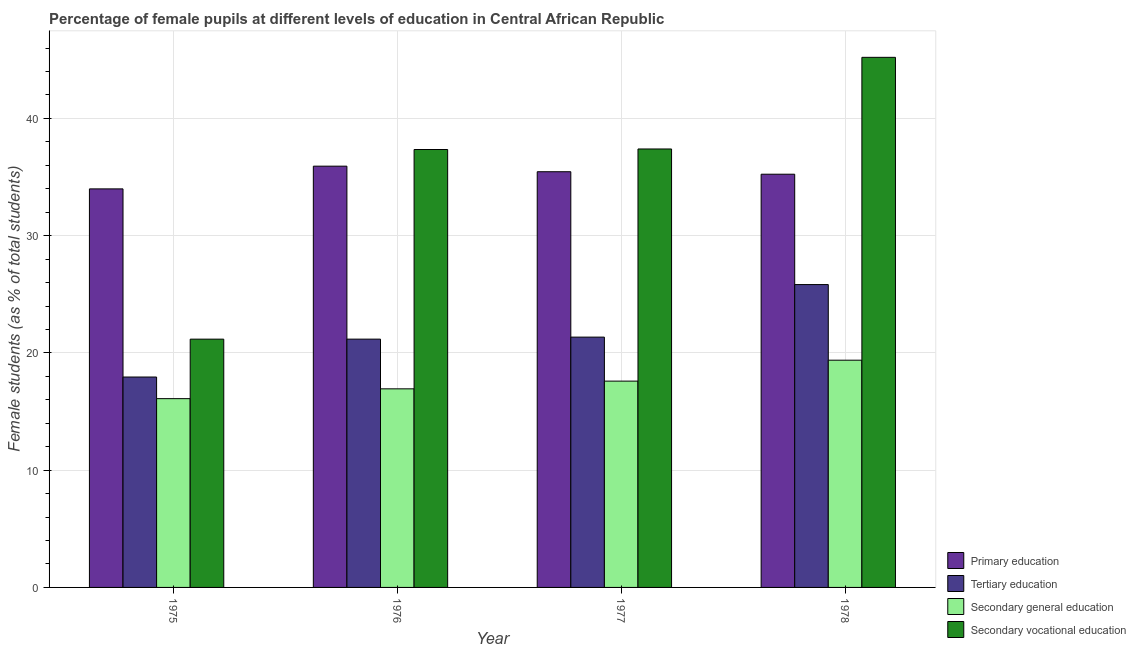Are the number of bars per tick equal to the number of legend labels?
Provide a short and direct response. Yes. What is the label of the 4th group of bars from the left?
Offer a very short reply. 1978. In how many cases, is the number of bars for a given year not equal to the number of legend labels?
Keep it short and to the point. 0. What is the percentage of female students in primary education in 1978?
Your response must be concise. 35.24. Across all years, what is the maximum percentage of female students in secondary education?
Your answer should be very brief. 19.38. Across all years, what is the minimum percentage of female students in secondary education?
Provide a succinct answer. 16.1. In which year was the percentage of female students in secondary education maximum?
Provide a succinct answer. 1978. In which year was the percentage of female students in tertiary education minimum?
Offer a terse response. 1975. What is the total percentage of female students in secondary education in the graph?
Offer a very short reply. 70.01. What is the difference between the percentage of female students in tertiary education in 1975 and that in 1976?
Your answer should be very brief. -3.23. What is the difference between the percentage of female students in tertiary education in 1976 and the percentage of female students in primary education in 1977?
Ensure brevity in your answer.  -0.17. What is the average percentage of female students in primary education per year?
Keep it short and to the point. 35.15. What is the ratio of the percentage of female students in secondary vocational education in 1977 to that in 1978?
Provide a succinct answer. 0.83. Is the difference between the percentage of female students in secondary education in 1975 and 1977 greater than the difference between the percentage of female students in primary education in 1975 and 1977?
Your answer should be very brief. No. What is the difference between the highest and the second highest percentage of female students in secondary education?
Provide a succinct answer. 1.78. What is the difference between the highest and the lowest percentage of female students in tertiary education?
Your response must be concise. 7.88. Is the sum of the percentage of female students in tertiary education in 1977 and 1978 greater than the maximum percentage of female students in primary education across all years?
Make the answer very short. Yes. What does the 2nd bar from the left in 1975 represents?
Offer a very short reply. Tertiary education. What does the 2nd bar from the right in 1978 represents?
Make the answer very short. Secondary general education. Are all the bars in the graph horizontal?
Your answer should be very brief. No. Are the values on the major ticks of Y-axis written in scientific E-notation?
Provide a short and direct response. No. Does the graph contain any zero values?
Make the answer very short. No. Does the graph contain grids?
Offer a very short reply. Yes. How are the legend labels stacked?
Your answer should be very brief. Vertical. What is the title of the graph?
Offer a very short reply. Percentage of female pupils at different levels of education in Central African Republic. What is the label or title of the X-axis?
Keep it short and to the point. Year. What is the label or title of the Y-axis?
Provide a short and direct response. Female students (as % of total students). What is the Female students (as % of total students) in Primary education in 1975?
Provide a short and direct response. 33.99. What is the Female students (as % of total students) in Tertiary education in 1975?
Offer a terse response. 17.94. What is the Female students (as % of total students) of Secondary general education in 1975?
Provide a short and direct response. 16.1. What is the Female students (as % of total students) in Secondary vocational education in 1975?
Your response must be concise. 21.17. What is the Female students (as % of total students) in Primary education in 1976?
Ensure brevity in your answer.  35.93. What is the Female students (as % of total students) of Tertiary education in 1976?
Provide a short and direct response. 21.18. What is the Female students (as % of total students) of Secondary general education in 1976?
Your answer should be compact. 16.94. What is the Female students (as % of total students) of Secondary vocational education in 1976?
Provide a succinct answer. 37.35. What is the Female students (as % of total students) in Primary education in 1977?
Your response must be concise. 35.45. What is the Female students (as % of total students) of Tertiary education in 1977?
Provide a short and direct response. 21.35. What is the Female students (as % of total students) in Secondary general education in 1977?
Your response must be concise. 17.6. What is the Female students (as % of total students) in Secondary vocational education in 1977?
Give a very brief answer. 37.39. What is the Female students (as % of total students) of Primary education in 1978?
Ensure brevity in your answer.  35.24. What is the Female students (as % of total students) in Tertiary education in 1978?
Ensure brevity in your answer.  25.83. What is the Female students (as % of total students) of Secondary general education in 1978?
Your answer should be very brief. 19.38. What is the Female students (as % of total students) in Secondary vocational education in 1978?
Your answer should be compact. 45.21. Across all years, what is the maximum Female students (as % of total students) in Primary education?
Provide a succinct answer. 35.93. Across all years, what is the maximum Female students (as % of total students) in Tertiary education?
Offer a terse response. 25.83. Across all years, what is the maximum Female students (as % of total students) in Secondary general education?
Offer a terse response. 19.38. Across all years, what is the maximum Female students (as % of total students) in Secondary vocational education?
Provide a short and direct response. 45.21. Across all years, what is the minimum Female students (as % of total students) of Primary education?
Keep it short and to the point. 33.99. Across all years, what is the minimum Female students (as % of total students) in Tertiary education?
Ensure brevity in your answer.  17.94. Across all years, what is the minimum Female students (as % of total students) of Secondary general education?
Your answer should be very brief. 16.1. Across all years, what is the minimum Female students (as % of total students) of Secondary vocational education?
Provide a short and direct response. 21.17. What is the total Female students (as % of total students) of Primary education in the graph?
Make the answer very short. 140.61. What is the total Female students (as % of total students) in Tertiary education in the graph?
Make the answer very short. 86.3. What is the total Female students (as % of total students) of Secondary general education in the graph?
Offer a terse response. 70.01. What is the total Female students (as % of total students) of Secondary vocational education in the graph?
Your response must be concise. 141.13. What is the difference between the Female students (as % of total students) of Primary education in 1975 and that in 1976?
Your response must be concise. -1.94. What is the difference between the Female students (as % of total students) of Tertiary education in 1975 and that in 1976?
Offer a very short reply. -3.23. What is the difference between the Female students (as % of total students) in Secondary general education in 1975 and that in 1976?
Give a very brief answer. -0.84. What is the difference between the Female students (as % of total students) in Secondary vocational education in 1975 and that in 1976?
Give a very brief answer. -16.17. What is the difference between the Female students (as % of total students) of Primary education in 1975 and that in 1977?
Provide a short and direct response. -1.46. What is the difference between the Female students (as % of total students) in Tertiary education in 1975 and that in 1977?
Keep it short and to the point. -3.4. What is the difference between the Female students (as % of total students) in Secondary general education in 1975 and that in 1977?
Keep it short and to the point. -1.5. What is the difference between the Female students (as % of total students) in Secondary vocational education in 1975 and that in 1977?
Give a very brief answer. -16.22. What is the difference between the Female students (as % of total students) in Primary education in 1975 and that in 1978?
Offer a terse response. -1.25. What is the difference between the Female students (as % of total students) of Tertiary education in 1975 and that in 1978?
Provide a short and direct response. -7.88. What is the difference between the Female students (as % of total students) in Secondary general education in 1975 and that in 1978?
Your response must be concise. -3.28. What is the difference between the Female students (as % of total students) in Secondary vocational education in 1975 and that in 1978?
Your answer should be compact. -24.04. What is the difference between the Female students (as % of total students) of Primary education in 1976 and that in 1977?
Provide a short and direct response. 0.47. What is the difference between the Female students (as % of total students) of Tertiary education in 1976 and that in 1977?
Offer a terse response. -0.17. What is the difference between the Female students (as % of total students) in Secondary general education in 1976 and that in 1977?
Provide a succinct answer. -0.66. What is the difference between the Female students (as % of total students) of Secondary vocational education in 1976 and that in 1977?
Provide a short and direct response. -0.05. What is the difference between the Female students (as % of total students) of Primary education in 1976 and that in 1978?
Offer a very short reply. 0.69. What is the difference between the Female students (as % of total students) in Tertiary education in 1976 and that in 1978?
Provide a succinct answer. -4.65. What is the difference between the Female students (as % of total students) in Secondary general education in 1976 and that in 1978?
Provide a short and direct response. -2.44. What is the difference between the Female students (as % of total students) in Secondary vocational education in 1976 and that in 1978?
Offer a very short reply. -7.86. What is the difference between the Female students (as % of total students) in Primary education in 1977 and that in 1978?
Keep it short and to the point. 0.21. What is the difference between the Female students (as % of total students) of Tertiary education in 1977 and that in 1978?
Provide a succinct answer. -4.48. What is the difference between the Female students (as % of total students) of Secondary general education in 1977 and that in 1978?
Provide a short and direct response. -1.78. What is the difference between the Female students (as % of total students) of Secondary vocational education in 1977 and that in 1978?
Give a very brief answer. -7.82. What is the difference between the Female students (as % of total students) of Primary education in 1975 and the Female students (as % of total students) of Tertiary education in 1976?
Provide a short and direct response. 12.81. What is the difference between the Female students (as % of total students) in Primary education in 1975 and the Female students (as % of total students) in Secondary general education in 1976?
Provide a succinct answer. 17.05. What is the difference between the Female students (as % of total students) of Primary education in 1975 and the Female students (as % of total students) of Secondary vocational education in 1976?
Your answer should be compact. -3.36. What is the difference between the Female students (as % of total students) in Tertiary education in 1975 and the Female students (as % of total students) in Secondary general education in 1976?
Provide a succinct answer. 1.01. What is the difference between the Female students (as % of total students) of Tertiary education in 1975 and the Female students (as % of total students) of Secondary vocational education in 1976?
Your answer should be compact. -19.4. What is the difference between the Female students (as % of total students) of Secondary general education in 1975 and the Female students (as % of total students) of Secondary vocational education in 1976?
Your response must be concise. -21.25. What is the difference between the Female students (as % of total students) in Primary education in 1975 and the Female students (as % of total students) in Tertiary education in 1977?
Give a very brief answer. 12.64. What is the difference between the Female students (as % of total students) in Primary education in 1975 and the Female students (as % of total students) in Secondary general education in 1977?
Your answer should be compact. 16.39. What is the difference between the Female students (as % of total students) of Primary education in 1975 and the Female students (as % of total students) of Secondary vocational education in 1977?
Your response must be concise. -3.4. What is the difference between the Female students (as % of total students) in Tertiary education in 1975 and the Female students (as % of total students) in Secondary general education in 1977?
Offer a terse response. 0.35. What is the difference between the Female students (as % of total students) of Tertiary education in 1975 and the Female students (as % of total students) of Secondary vocational education in 1977?
Give a very brief answer. -19.45. What is the difference between the Female students (as % of total students) of Secondary general education in 1975 and the Female students (as % of total students) of Secondary vocational education in 1977?
Give a very brief answer. -21.29. What is the difference between the Female students (as % of total students) in Primary education in 1975 and the Female students (as % of total students) in Tertiary education in 1978?
Make the answer very short. 8.16. What is the difference between the Female students (as % of total students) in Primary education in 1975 and the Female students (as % of total students) in Secondary general education in 1978?
Ensure brevity in your answer.  14.61. What is the difference between the Female students (as % of total students) of Primary education in 1975 and the Female students (as % of total students) of Secondary vocational education in 1978?
Provide a succinct answer. -11.22. What is the difference between the Female students (as % of total students) of Tertiary education in 1975 and the Female students (as % of total students) of Secondary general education in 1978?
Offer a very short reply. -1.43. What is the difference between the Female students (as % of total students) of Tertiary education in 1975 and the Female students (as % of total students) of Secondary vocational education in 1978?
Offer a terse response. -27.27. What is the difference between the Female students (as % of total students) in Secondary general education in 1975 and the Female students (as % of total students) in Secondary vocational education in 1978?
Offer a terse response. -29.11. What is the difference between the Female students (as % of total students) in Primary education in 1976 and the Female students (as % of total students) in Tertiary education in 1977?
Your response must be concise. 14.58. What is the difference between the Female students (as % of total students) of Primary education in 1976 and the Female students (as % of total students) of Secondary general education in 1977?
Make the answer very short. 18.33. What is the difference between the Female students (as % of total students) in Primary education in 1976 and the Female students (as % of total students) in Secondary vocational education in 1977?
Keep it short and to the point. -1.47. What is the difference between the Female students (as % of total students) in Tertiary education in 1976 and the Female students (as % of total students) in Secondary general education in 1977?
Provide a succinct answer. 3.58. What is the difference between the Female students (as % of total students) in Tertiary education in 1976 and the Female students (as % of total students) in Secondary vocational education in 1977?
Offer a terse response. -16.22. What is the difference between the Female students (as % of total students) in Secondary general education in 1976 and the Female students (as % of total students) in Secondary vocational education in 1977?
Give a very brief answer. -20.46. What is the difference between the Female students (as % of total students) of Primary education in 1976 and the Female students (as % of total students) of Tertiary education in 1978?
Offer a terse response. 10.1. What is the difference between the Female students (as % of total students) of Primary education in 1976 and the Female students (as % of total students) of Secondary general education in 1978?
Give a very brief answer. 16.55. What is the difference between the Female students (as % of total students) of Primary education in 1976 and the Female students (as % of total students) of Secondary vocational education in 1978?
Offer a terse response. -9.28. What is the difference between the Female students (as % of total students) in Tertiary education in 1976 and the Female students (as % of total students) in Secondary general education in 1978?
Your response must be concise. 1.8. What is the difference between the Female students (as % of total students) of Tertiary education in 1976 and the Female students (as % of total students) of Secondary vocational education in 1978?
Your answer should be very brief. -24.03. What is the difference between the Female students (as % of total students) of Secondary general education in 1976 and the Female students (as % of total students) of Secondary vocational education in 1978?
Make the answer very short. -28.27. What is the difference between the Female students (as % of total students) in Primary education in 1977 and the Female students (as % of total students) in Tertiary education in 1978?
Keep it short and to the point. 9.62. What is the difference between the Female students (as % of total students) of Primary education in 1977 and the Female students (as % of total students) of Secondary general education in 1978?
Provide a succinct answer. 16.07. What is the difference between the Female students (as % of total students) of Primary education in 1977 and the Female students (as % of total students) of Secondary vocational education in 1978?
Make the answer very short. -9.76. What is the difference between the Female students (as % of total students) of Tertiary education in 1977 and the Female students (as % of total students) of Secondary general education in 1978?
Your response must be concise. 1.97. What is the difference between the Female students (as % of total students) of Tertiary education in 1977 and the Female students (as % of total students) of Secondary vocational education in 1978?
Your response must be concise. -23.86. What is the difference between the Female students (as % of total students) in Secondary general education in 1977 and the Female students (as % of total students) in Secondary vocational education in 1978?
Provide a short and direct response. -27.61. What is the average Female students (as % of total students) in Primary education per year?
Your answer should be very brief. 35.15. What is the average Female students (as % of total students) in Tertiary education per year?
Keep it short and to the point. 21.57. What is the average Female students (as % of total students) in Secondary general education per year?
Give a very brief answer. 17.5. What is the average Female students (as % of total students) in Secondary vocational education per year?
Make the answer very short. 35.28. In the year 1975, what is the difference between the Female students (as % of total students) in Primary education and Female students (as % of total students) in Tertiary education?
Keep it short and to the point. 16.05. In the year 1975, what is the difference between the Female students (as % of total students) in Primary education and Female students (as % of total students) in Secondary general education?
Provide a succinct answer. 17.89. In the year 1975, what is the difference between the Female students (as % of total students) in Primary education and Female students (as % of total students) in Secondary vocational education?
Ensure brevity in your answer.  12.82. In the year 1975, what is the difference between the Female students (as % of total students) in Tertiary education and Female students (as % of total students) in Secondary general education?
Offer a terse response. 1.84. In the year 1975, what is the difference between the Female students (as % of total students) of Tertiary education and Female students (as % of total students) of Secondary vocational education?
Ensure brevity in your answer.  -3.23. In the year 1975, what is the difference between the Female students (as % of total students) of Secondary general education and Female students (as % of total students) of Secondary vocational education?
Offer a very short reply. -5.07. In the year 1976, what is the difference between the Female students (as % of total students) in Primary education and Female students (as % of total students) in Tertiary education?
Give a very brief answer. 14.75. In the year 1976, what is the difference between the Female students (as % of total students) of Primary education and Female students (as % of total students) of Secondary general education?
Give a very brief answer. 18.99. In the year 1976, what is the difference between the Female students (as % of total students) in Primary education and Female students (as % of total students) in Secondary vocational education?
Give a very brief answer. -1.42. In the year 1976, what is the difference between the Female students (as % of total students) in Tertiary education and Female students (as % of total students) in Secondary general education?
Keep it short and to the point. 4.24. In the year 1976, what is the difference between the Female students (as % of total students) of Tertiary education and Female students (as % of total students) of Secondary vocational education?
Your answer should be compact. -16.17. In the year 1976, what is the difference between the Female students (as % of total students) in Secondary general education and Female students (as % of total students) in Secondary vocational education?
Offer a very short reply. -20.41. In the year 1977, what is the difference between the Female students (as % of total students) of Primary education and Female students (as % of total students) of Tertiary education?
Ensure brevity in your answer.  14.11. In the year 1977, what is the difference between the Female students (as % of total students) of Primary education and Female students (as % of total students) of Secondary general education?
Your answer should be compact. 17.86. In the year 1977, what is the difference between the Female students (as % of total students) in Primary education and Female students (as % of total students) in Secondary vocational education?
Offer a terse response. -1.94. In the year 1977, what is the difference between the Female students (as % of total students) in Tertiary education and Female students (as % of total students) in Secondary general education?
Make the answer very short. 3.75. In the year 1977, what is the difference between the Female students (as % of total students) of Tertiary education and Female students (as % of total students) of Secondary vocational education?
Make the answer very short. -16.05. In the year 1977, what is the difference between the Female students (as % of total students) in Secondary general education and Female students (as % of total students) in Secondary vocational education?
Your response must be concise. -19.8. In the year 1978, what is the difference between the Female students (as % of total students) of Primary education and Female students (as % of total students) of Tertiary education?
Your response must be concise. 9.41. In the year 1978, what is the difference between the Female students (as % of total students) in Primary education and Female students (as % of total students) in Secondary general education?
Your response must be concise. 15.86. In the year 1978, what is the difference between the Female students (as % of total students) in Primary education and Female students (as % of total students) in Secondary vocational education?
Offer a terse response. -9.97. In the year 1978, what is the difference between the Female students (as % of total students) in Tertiary education and Female students (as % of total students) in Secondary general education?
Provide a succinct answer. 6.45. In the year 1978, what is the difference between the Female students (as % of total students) in Tertiary education and Female students (as % of total students) in Secondary vocational education?
Keep it short and to the point. -19.38. In the year 1978, what is the difference between the Female students (as % of total students) of Secondary general education and Female students (as % of total students) of Secondary vocational education?
Your answer should be compact. -25.83. What is the ratio of the Female students (as % of total students) in Primary education in 1975 to that in 1976?
Ensure brevity in your answer.  0.95. What is the ratio of the Female students (as % of total students) in Tertiary education in 1975 to that in 1976?
Provide a succinct answer. 0.85. What is the ratio of the Female students (as % of total students) of Secondary general education in 1975 to that in 1976?
Your answer should be very brief. 0.95. What is the ratio of the Female students (as % of total students) of Secondary vocational education in 1975 to that in 1976?
Provide a succinct answer. 0.57. What is the ratio of the Female students (as % of total students) of Primary education in 1975 to that in 1977?
Your answer should be very brief. 0.96. What is the ratio of the Female students (as % of total students) in Tertiary education in 1975 to that in 1977?
Keep it short and to the point. 0.84. What is the ratio of the Female students (as % of total students) in Secondary general education in 1975 to that in 1977?
Provide a short and direct response. 0.92. What is the ratio of the Female students (as % of total students) of Secondary vocational education in 1975 to that in 1977?
Offer a very short reply. 0.57. What is the ratio of the Female students (as % of total students) of Primary education in 1975 to that in 1978?
Keep it short and to the point. 0.96. What is the ratio of the Female students (as % of total students) in Tertiary education in 1975 to that in 1978?
Provide a short and direct response. 0.69. What is the ratio of the Female students (as % of total students) of Secondary general education in 1975 to that in 1978?
Offer a very short reply. 0.83. What is the ratio of the Female students (as % of total students) of Secondary vocational education in 1975 to that in 1978?
Your answer should be compact. 0.47. What is the ratio of the Female students (as % of total students) in Primary education in 1976 to that in 1977?
Your response must be concise. 1.01. What is the ratio of the Female students (as % of total students) in Secondary general education in 1976 to that in 1977?
Give a very brief answer. 0.96. What is the ratio of the Female students (as % of total students) in Primary education in 1976 to that in 1978?
Your answer should be compact. 1.02. What is the ratio of the Female students (as % of total students) of Tertiary education in 1976 to that in 1978?
Your answer should be compact. 0.82. What is the ratio of the Female students (as % of total students) of Secondary general education in 1976 to that in 1978?
Offer a very short reply. 0.87. What is the ratio of the Female students (as % of total students) in Secondary vocational education in 1976 to that in 1978?
Your response must be concise. 0.83. What is the ratio of the Female students (as % of total students) in Tertiary education in 1977 to that in 1978?
Provide a short and direct response. 0.83. What is the ratio of the Female students (as % of total students) in Secondary general education in 1977 to that in 1978?
Provide a succinct answer. 0.91. What is the ratio of the Female students (as % of total students) in Secondary vocational education in 1977 to that in 1978?
Give a very brief answer. 0.83. What is the difference between the highest and the second highest Female students (as % of total students) of Primary education?
Offer a very short reply. 0.47. What is the difference between the highest and the second highest Female students (as % of total students) in Tertiary education?
Your answer should be very brief. 4.48. What is the difference between the highest and the second highest Female students (as % of total students) in Secondary general education?
Your response must be concise. 1.78. What is the difference between the highest and the second highest Female students (as % of total students) of Secondary vocational education?
Provide a short and direct response. 7.82. What is the difference between the highest and the lowest Female students (as % of total students) in Primary education?
Offer a terse response. 1.94. What is the difference between the highest and the lowest Female students (as % of total students) in Tertiary education?
Provide a short and direct response. 7.88. What is the difference between the highest and the lowest Female students (as % of total students) of Secondary general education?
Your answer should be very brief. 3.28. What is the difference between the highest and the lowest Female students (as % of total students) in Secondary vocational education?
Ensure brevity in your answer.  24.04. 